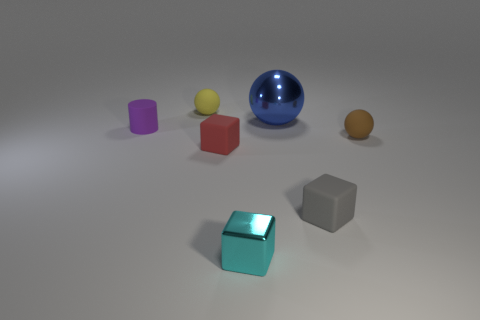What color is the small block that is both behind the cyan shiny thing and to the left of the metallic ball?
Make the answer very short. Red. What is the size of the other metal object that is the same shape as the brown object?
Your answer should be very brief. Large. How many yellow rubber balls have the same size as the brown rubber ball?
Your answer should be very brief. 1. What material is the large object?
Provide a short and direct response. Metal. There is a brown object; are there any small matte spheres behind it?
Ensure brevity in your answer.  Yes. The blue ball that is made of the same material as the tiny cyan object is what size?
Make the answer very short. Large. How many other shiny spheres have the same color as the large ball?
Provide a short and direct response. 0. Is the number of blue metallic balls behind the big shiny thing less than the number of small cyan cubes in front of the brown rubber ball?
Offer a terse response. Yes. There is a matte ball to the right of the cyan shiny thing; what is its size?
Your response must be concise. Small. Are there any other tiny balls made of the same material as the brown sphere?
Keep it short and to the point. Yes. 